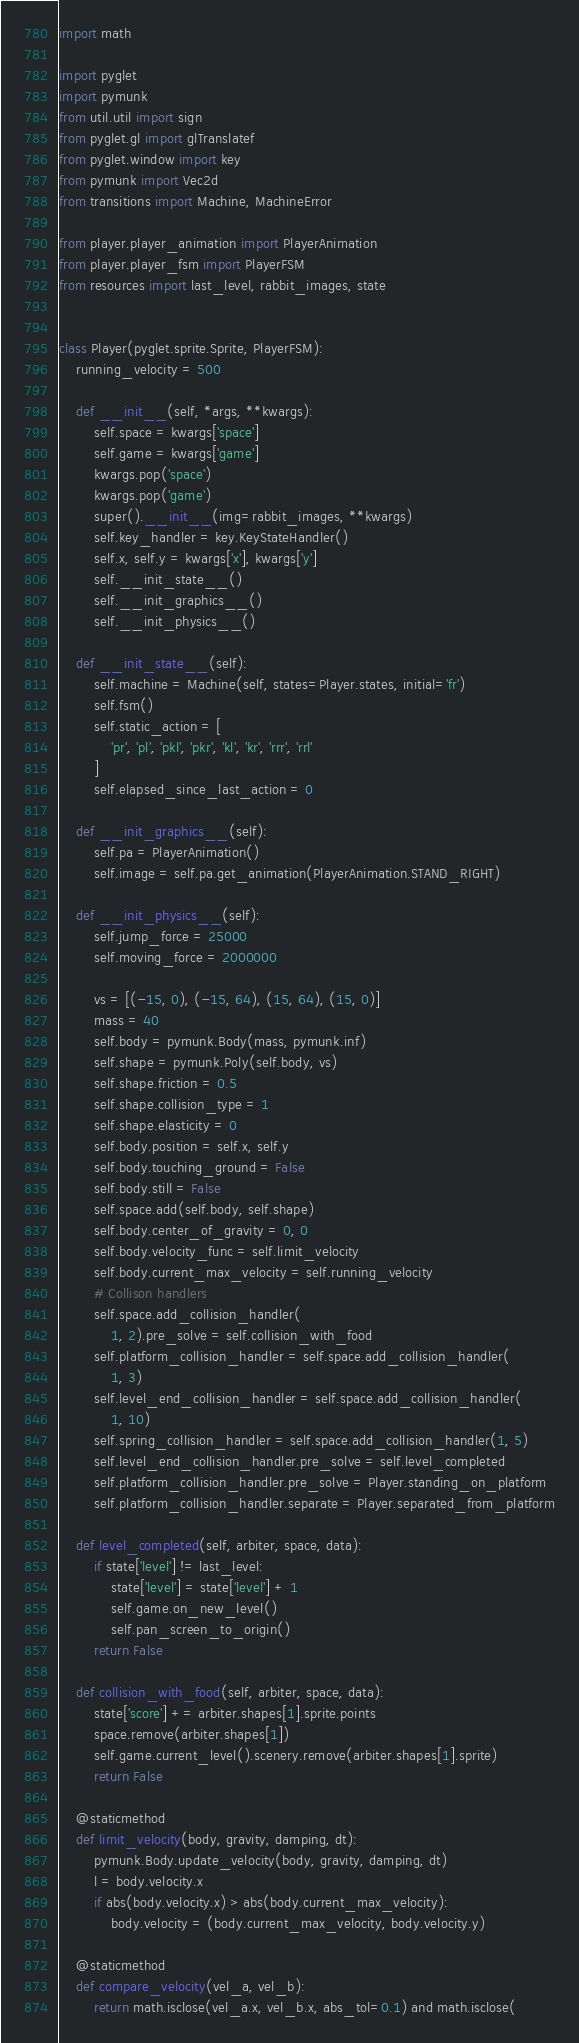<code> <loc_0><loc_0><loc_500><loc_500><_Python_>import math

import pyglet
import pymunk
from util.util import sign
from pyglet.gl import glTranslatef
from pyglet.window import key
from pymunk import Vec2d
from transitions import Machine, MachineError

from player.player_animation import PlayerAnimation
from player.player_fsm import PlayerFSM
from resources import last_level, rabbit_images, state


class Player(pyglet.sprite.Sprite, PlayerFSM):
    running_velocity = 500

    def __init__(self, *args, **kwargs):
        self.space = kwargs['space']
        self.game = kwargs['game']
        kwargs.pop('space')
        kwargs.pop('game')
        super().__init__(img=rabbit_images, **kwargs)
        self.key_handler = key.KeyStateHandler()
        self.x, self.y = kwargs['x'], kwargs['y']
        self.__init_state__()
        self.__init_graphics__()
        self.__init_physics__()

    def __init_state__(self):
        self.machine = Machine(self, states=Player.states, initial='fr')
        self.fsm()
        self.static_action = [
            'pr', 'pl', 'pkl', 'pkr', 'kl', 'kr', 'rrr', 'rrl'
        ]
        self.elapsed_since_last_action = 0

    def __init_graphics__(self):
        self.pa = PlayerAnimation()
        self.image = self.pa.get_animation(PlayerAnimation.STAND_RIGHT)

    def __init_physics__(self):
        self.jump_force = 25000
        self.moving_force = 2000000

        vs = [(-15, 0), (-15, 64), (15, 64), (15, 0)]
        mass = 40
        self.body = pymunk.Body(mass, pymunk.inf)
        self.shape = pymunk.Poly(self.body, vs)
        self.shape.friction = 0.5
        self.shape.collision_type = 1
        self.shape.elasticity = 0
        self.body.position = self.x, self.y
        self.body.touching_ground = False
        self.body.still = False
        self.space.add(self.body, self.shape)
        self.body.center_of_gravity = 0, 0
        self.body.velocity_func = self.limit_velocity
        self.body.current_max_velocity = self.running_velocity
        # Collison handlers
        self.space.add_collision_handler(
            1, 2).pre_solve = self.collision_with_food
        self.platform_collision_handler = self.space.add_collision_handler(
            1, 3)
        self.level_end_collision_handler = self.space.add_collision_handler(
            1, 10)
        self.spring_collision_handler = self.space.add_collision_handler(1, 5)
        self.level_end_collision_handler.pre_solve = self.level_completed
        self.platform_collision_handler.pre_solve = Player.standing_on_platform
        self.platform_collision_handler.separate = Player.separated_from_platform

    def level_completed(self, arbiter, space, data):
        if state['level'] != last_level:
            state['level'] = state['level'] + 1
            self.game.on_new_level()
            self.pan_screen_to_origin()
        return False

    def collision_with_food(self, arbiter, space, data):
        state['score'] += arbiter.shapes[1].sprite.points
        space.remove(arbiter.shapes[1])
        self.game.current_level().scenery.remove(arbiter.shapes[1].sprite)
        return False

    @staticmethod
    def limit_velocity(body, gravity, damping, dt):
        pymunk.Body.update_velocity(body, gravity, damping, dt)
        l = body.velocity.x
        if abs(body.velocity.x) > abs(body.current_max_velocity):
            body.velocity = (body.current_max_velocity, body.velocity.y)

    @staticmethod
    def compare_velocity(vel_a, vel_b):
        return math.isclose(vel_a.x, vel_b.x, abs_tol=0.1) and math.isclose(</code> 